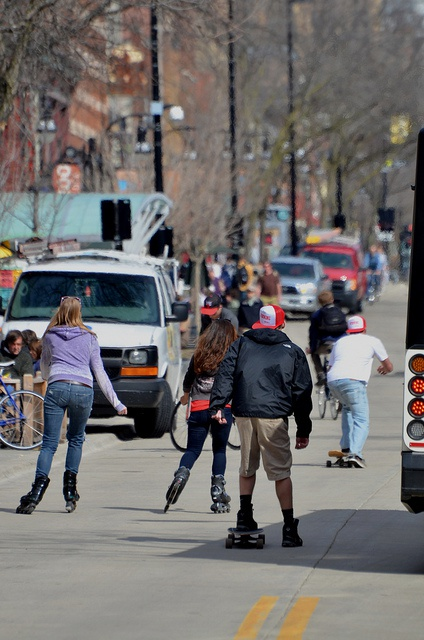Describe the objects in this image and their specific colors. I can see truck in black, lightgray, blue, and gray tones, people in black, gray, and darkblue tones, people in black, darkgray, gray, and blue tones, bus in black, lightgray, and gray tones, and people in black, gray, maroon, and darkgray tones in this image. 